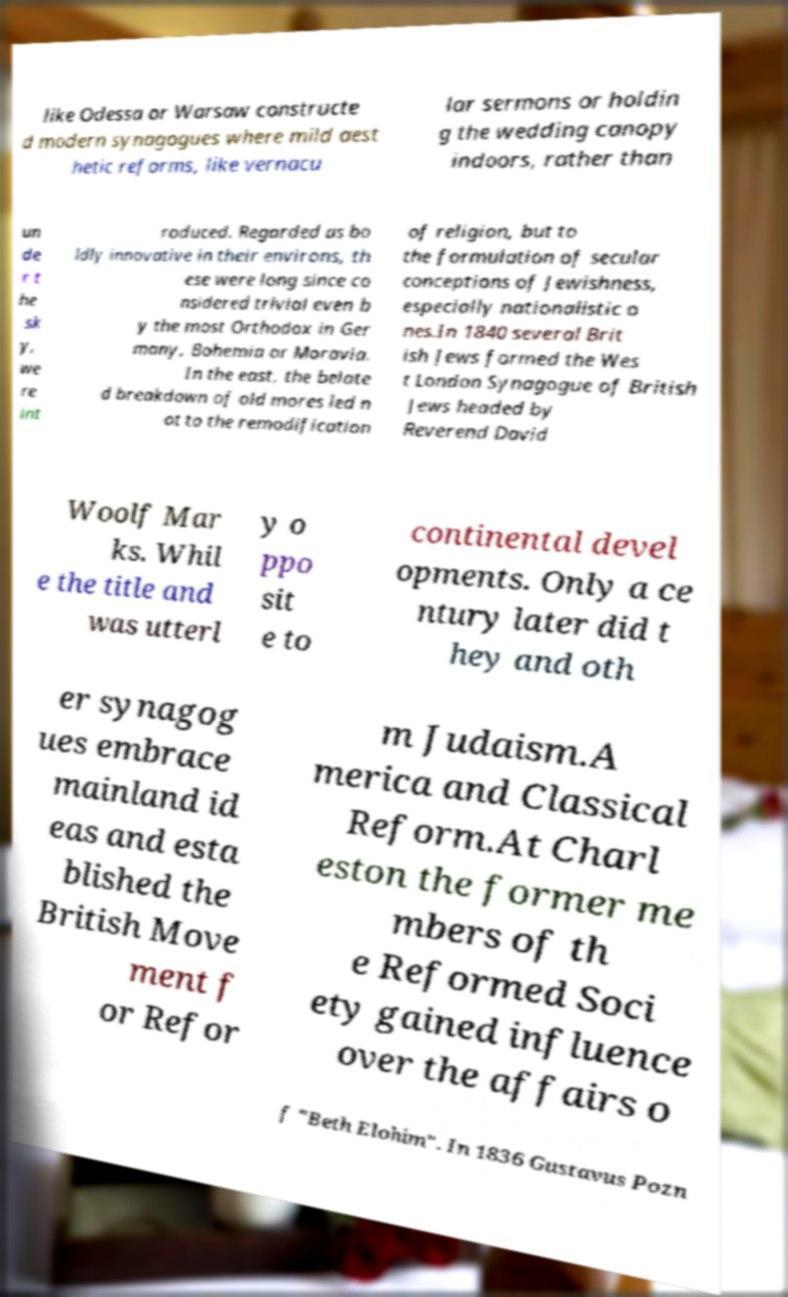I need the written content from this picture converted into text. Can you do that? like Odessa or Warsaw constructe d modern synagogues where mild aest hetic reforms, like vernacu lar sermons or holdin g the wedding canopy indoors, rather than un de r t he sk y, we re int roduced. Regarded as bo ldly innovative in their environs, th ese were long since co nsidered trivial even b y the most Orthodox in Ger many, Bohemia or Moravia. In the east, the belate d breakdown of old mores led n ot to the remodification of religion, but to the formulation of secular conceptions of Jewishness, especially nationalistic o nes.In 1840 several Brit ish Jews formed the Wes t London Synagogue of British Jews headed by Reverend David Woolf Mar ks. Whil e the title and was utterl y o ppo sit e to continental devel opments. Only a ce ntury later did t hey and oth er synagog ues embrace mainland id eas and esta blished the British Move ment f or Refor m Judaism.A merica and Classical Reform.At Charl eston the former me mbers of th e Reformed Soci ety gained influence over the affairs o f "Beth Elohim". In 1836 Gustavus Pozn 